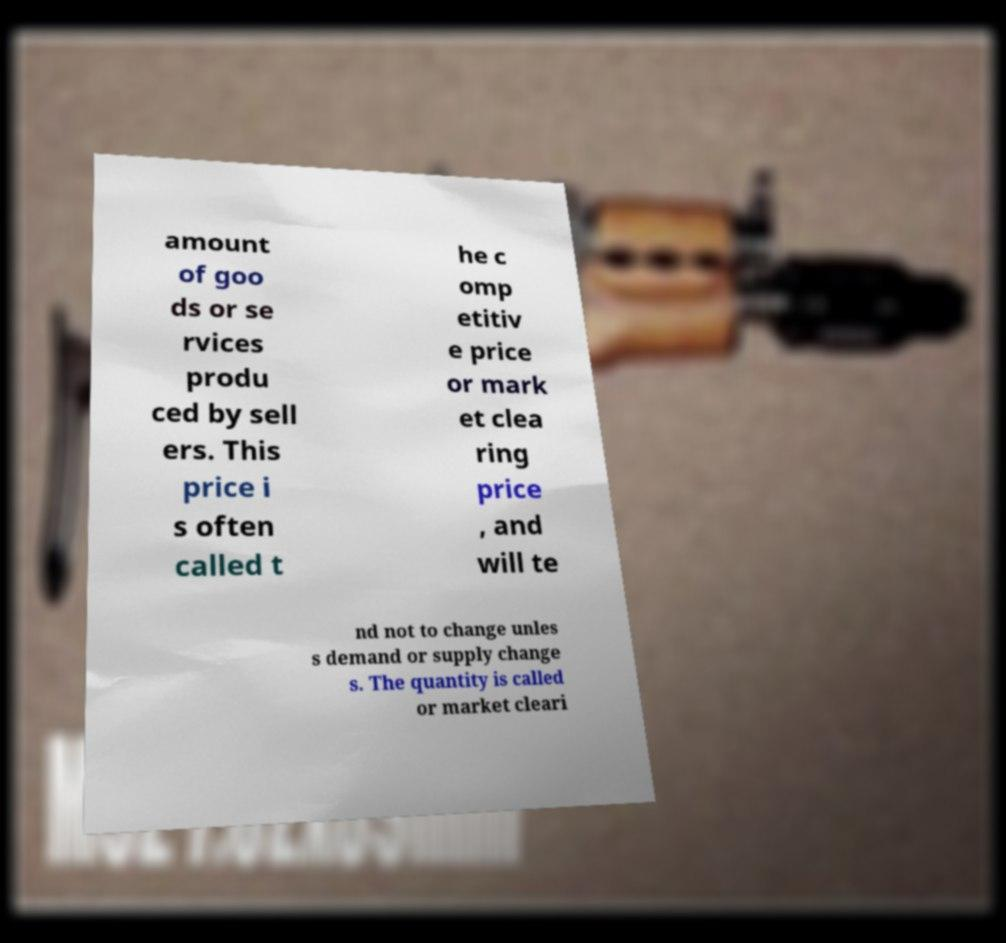What messages or text are displayed in this image? I need them in a readable, typed format. amount of goo ds or se rvices produ ced by sell ers. This price i s often called t he c omp etitiv e price or mark et clea ring price , and will te nd not to change unles s demand or supply change s. The quantity is called or market cleari 